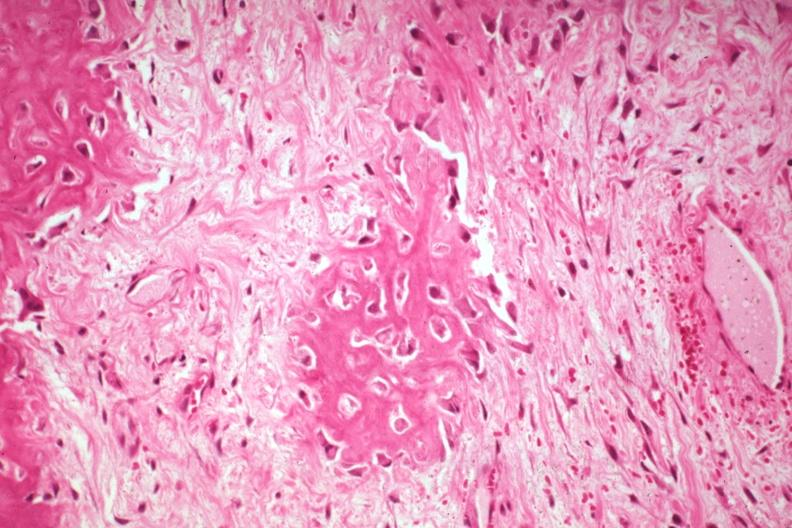does this image show high fibrous callus and osteoid with osteoblasts from a non-union?
Answer the question using a single word or phrase. Yes 